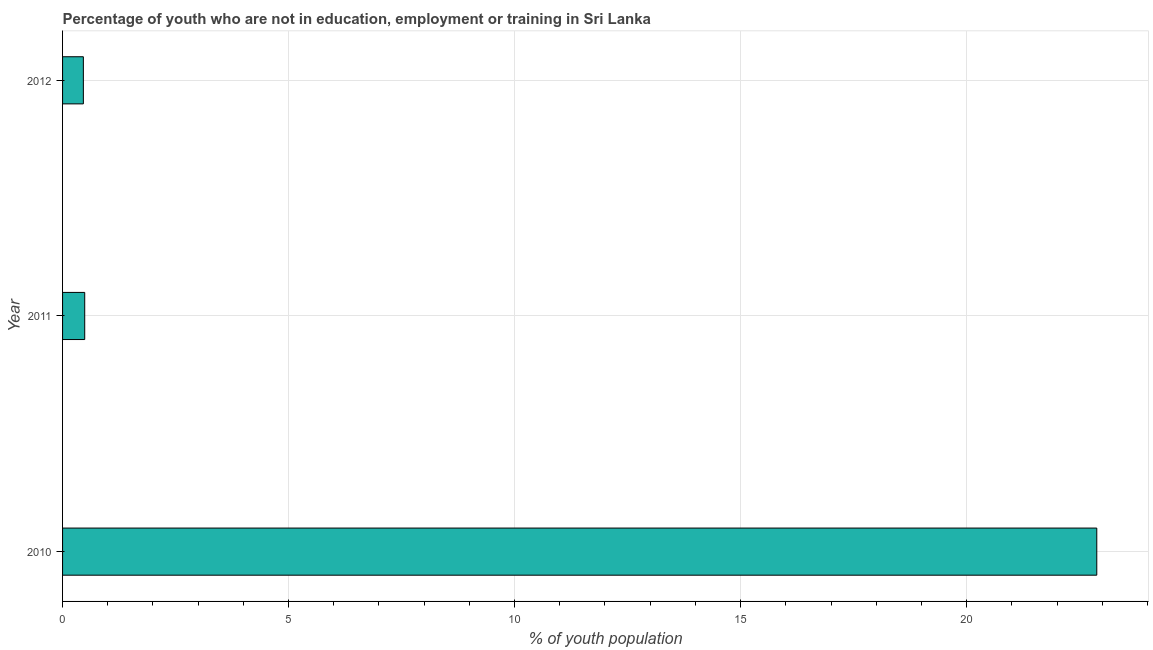Does the graph contain any zero values?
Your answer should be compact. No. Does the graph contain grids?
Make the answer very short. Yes. What is the title of the graph?
Give a very brief answer. Percentage of youth who are not in education, employment or training in Sri Lanka. What is the label or title of the X-axis?
Provide a succinct answer. % of youth population. What is the label or title of the Y-axis?
Give a very brief answer. Year. What is the unemployed youth population in 2010?
Keep it short and to the point. 22.88. Across all years, what is the maximum unemployed youth population?
Your answer should be very brief. 22.88. Across all years, what is the minimum unemployed youth population?
Give a very brief answer. 0.46. In which year was the unemployed youth population maximum?
Your answer should be very brief. 2010. In which year was the unemployed youth population minimum?
Keep it short and to the point. 2012. What is the sum of the unemployed youth population?
Provide a short and direct response. 23.83. What is the average unemployed youth population per year?
Your answer should be compact. 7.94. What is the median unemployed youth population?
Your response must be concise. 0.49. What is the ratio of the unemployed youth population in 2010 to that in 2011?
Give a very brief answer. 46.69. Is the difference between the unemployed youth population in 2011 and 2012 greater than the difference between any two years?
Your response must be concise. No. What is the difference between the highest and the second highest unemployed youth population?
Your response must be concise. 22.39. Is the sum of the unemployed youth population in 2011 and 2012 greater than the maximum unemployed youth population across all years?
Ensure brevity in your answer.  No. What is the difference between the highest and the lowest unemployed youth population?
Provide a succinct answer. 22.42. Are all the bars in the graph horizontal?
Provide a succinct answer. Yes. How many years are there in the graph?
Give a very brief answer. 3. What is the % of youth population of 2010?
Keep it short and to the point. 22.88. What is the % of youth population of 2011?
Keep it short and to the point. 0.49. What is the % of youth population in 2012?
Your response must be concise. 0.46. What is the difference between the % of youth population in 2010 and 2011?
Keep it short and to the point. 22.39. What is the difference between the % of youth population in 2010 and 2012?
Provide a short and direct response. 22.42. What is the difference between the % of youth population in 2011 and 2012?
Offer a very short reply. 0.03. What is the ratio of the % of youth population in 2010 to that in 2011?
Give a very brief answer. 46.69. What is the ratio of the % of youth population in 2010 to that in 2012?
Keep it short and to the point. 49.74. What is the ratio of the % of youth population in 2011 to that in 2012?
Ensure brevity in your answer.  1.06. 